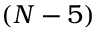Convert formula to latex. <formula><loc_0><loc_0><loc_500><loc_500>( N - 5 )</formula> 